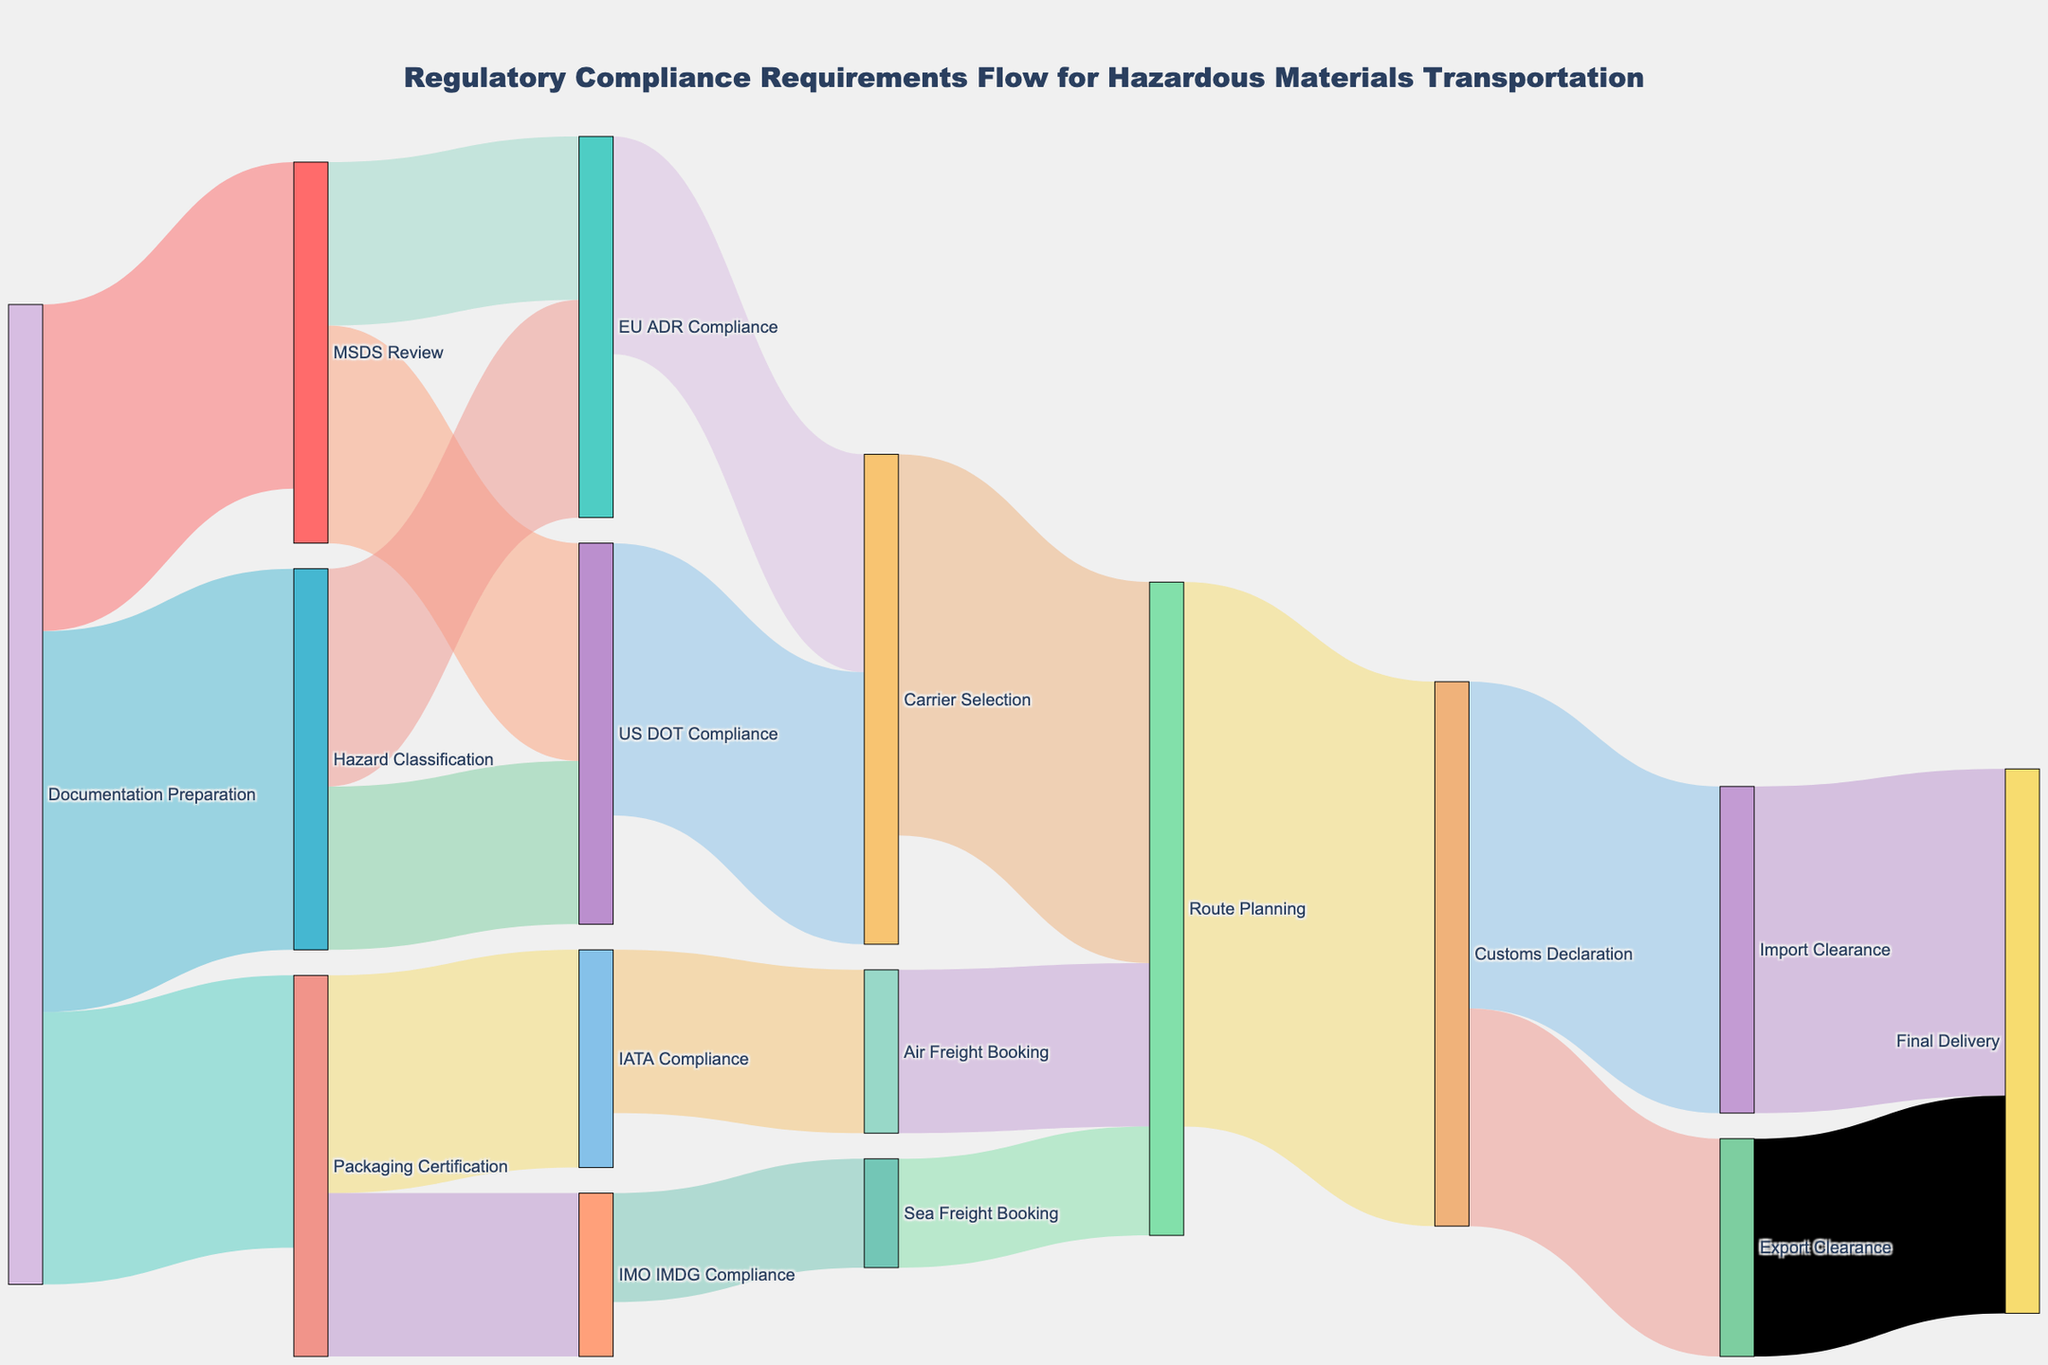How many steps are involved from "Documentation Preparation" to the final 'Final Delivery'? Starting from "Documentation Preparation," the flow goes through the following nodes: "MSDS Review,” "US DOT Compliance,” "Carrier Selection,” "Route Planning,” "Customs Declaration,” "Import Clearance,” to reach "Final Delivery." This totals 7 steps.
Answer: 7 Which compliance step involves both air and sea freight booking? The "Packaging Certification" step leads to both "IATA Compliance" for air freight booking and "IMO IMDG Compliance" for sea freight booking.
Answer: Packaging Certification What's the sum of values flowing out from "Route Planning"? The flows from "Route Planning" are towards "Customs Declaration" with a value of 50. Sum = 50.
Answer: 50 Which compliance requirement has the lowest value, and what is that value? The path from "Sea Freight Booking" to "Route Planning" has the lowest value of 10.
Answer: Sea Freight Booking to Route Planning, 10 Is there any node that feeds into both "US DOT Compliance" and "EU ADR Compliance"? Yes, "MSDS Review" sends flows to both "US DOT Compliance" and "EU ADR Compliance," and "Hazard Classification" also sends flows to both.
Answer: MSDS Review, Hazard Classification What is the total amount of flow going to "Route Planning"? The incoming flows to "Route Planning" are from "Carrier Selection" (35), "Air Freight Booking" (15), and "Sea Freight Booking" (10). The sum is 35 + 15 + 10 = 60.
Answer: 60 Does every compliance requirement lead to either "Air Freight Booking" or "Sea Freight Booking"? Not every compliance requirement leads directly to "Air Freight Booking" or "Sea Freight Booking." Some lead to other steps like "Carrier Selection."
Answer: No Which initial step has the most branches flowing out of it? "Documentation Preparation" has three branches flowing out of it: "MSDS Review,” "Packaging Certification,” and "Hazard Classification."
Answer: Documentation Preparation After passing through "Customs Declaration," how is the material flow distributed? The flow from "Customs Declaration" splits into "Import Clearance" (30) and "Export Clearance" (20).
Answer: Import Clearance, 30; Export Clearance, 20 What's the predominant path for "Documentation Preparation" leading up to the final delivery? "Documentation Preparation" → "MSDS Review" → "US DOT Compliance" → "Carrier Selection" → "Route Planning" → "Customs Declaration" → "Import Clearance" → "Final Delivery" is a major path involving large flows.
Answer: Documentation Preparation → MSDS Review → US DOT Compliance → Carrier Selection → Route Planning → Customs Declaration → Import Clearance → Final Delivery 